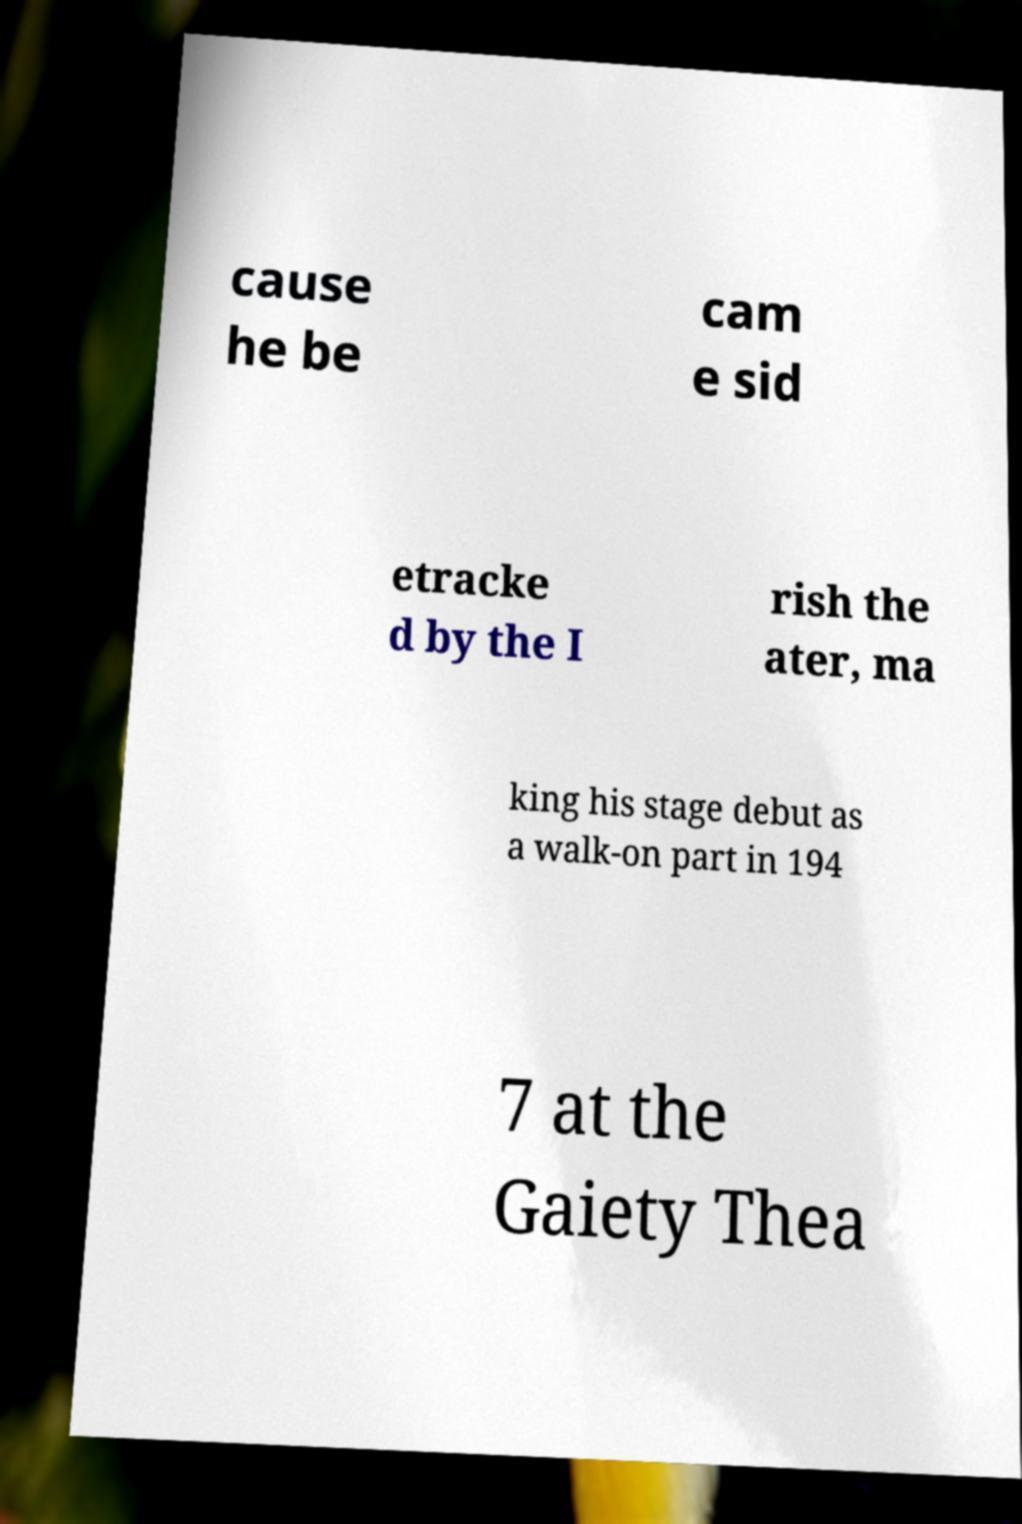Could you assist in decoding the text presented in this image and type it out clearly? cause he be cam e sid etracke d by the I rish the ater, ma king his stage debut as a walk-on part in 194 7 at the Gaiety Thea 